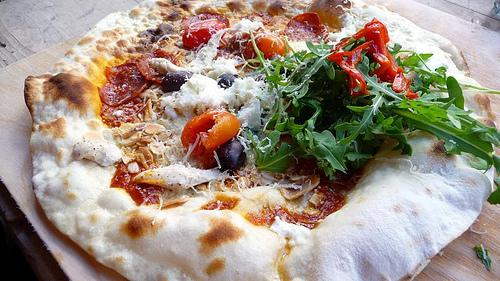Question: how many pizzas are on the table?
Choices:
A. 2.
B. 3.
C. 4.
D. 1.
Answer with the letter. Answer: D Question: where is the cheese located on the pizza?
Choices:
A. In the crust.
B. In the middle.
C. Underneath the pepperonis.
D. On top.
Answer with the letter. Answer: D Question: what two main colors are on top the pizza?
Choices:
A. White and yellow.
B. Red and green.
C. Red and yellow.
D. Brown and red.
Answer with the letter. Answer: B Question: how many pieces of pizza are cut?
Choices:
A. 1.
B. 2.
C. 3.
D. 0.
Answer with the letter. Answer: D 